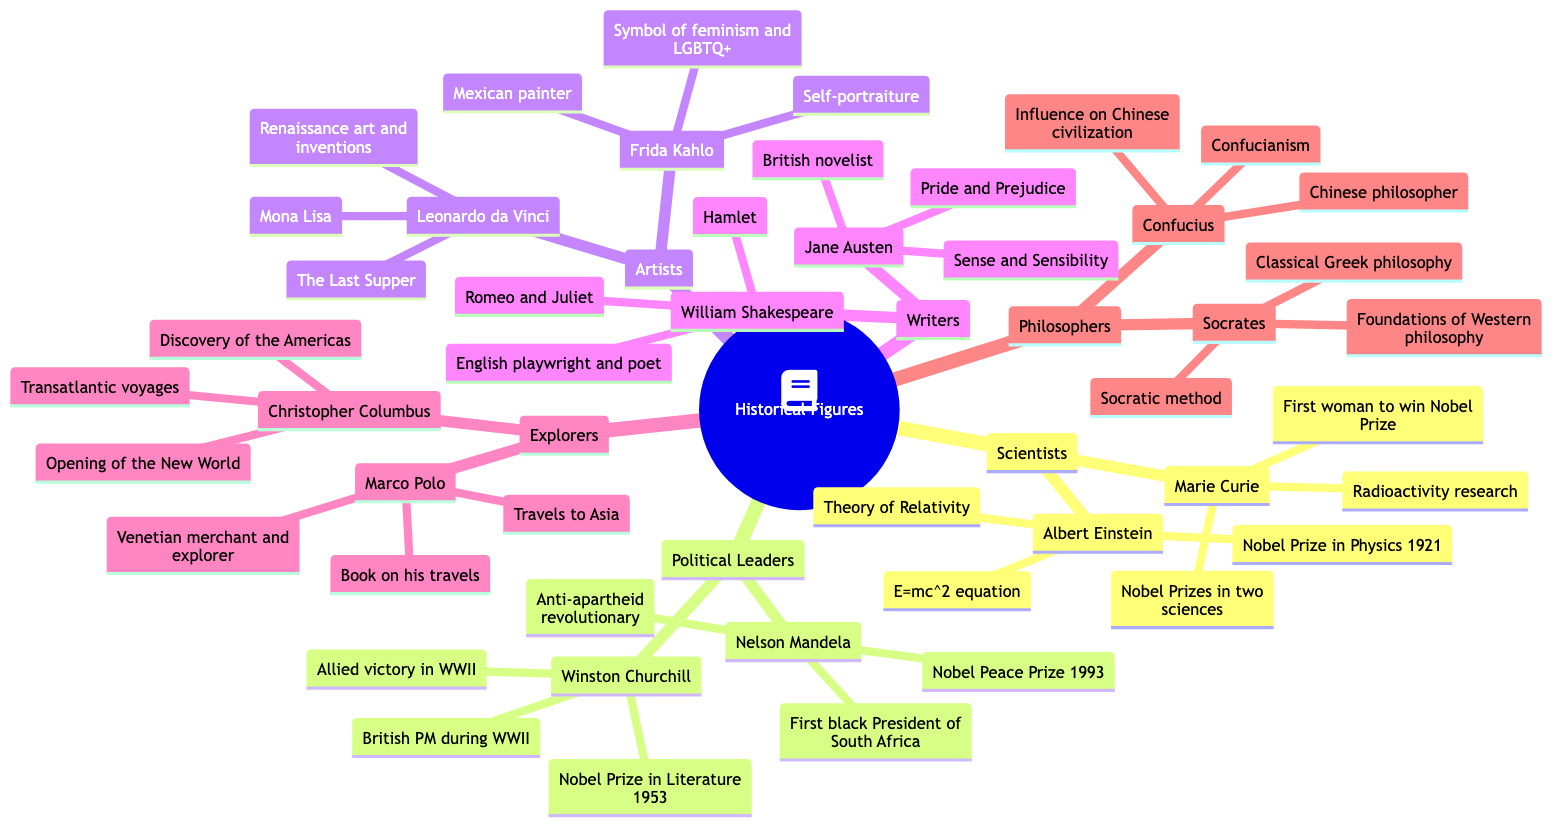What is Marie Curie known for? The diagram states that Marie Curie is known for "Radioactivity research." This is a direct line from her name to the known for category.
Answer: Radioactivity research How many political leaders are listed? The diagram shows two political leaders: Nelson Mandela and Winston Churchill, which can be counted directly from their respective nodes.
Answer: 2 Which artist created the "Mona Lisa"? The diagram indicates that Leonardo da Vinci is known for "Renaissance art and inventions" and specifically notes the "Mona Lisa" as one of his achievements.
Answer: Leonardo da Vinci What was Albert Einstein's major contribution? The diagram provides the information that Albert Einstein is known for the "Theory of Relativity," a significant contribution in the field of physics.
Answer: Theory of Relativity Who is recognized as the first black President of South Africa? According to the diagram, Nelson Mandela is specifically noted as the "First black President of South Africa," which is clearly stated in his achievements.
Answer: Nelson Mandela Which philosopher is linked with the Socratic method? By examining the diagram, Socrates is directly associated with the "Socratic method" under his achievements, linking him uniquely to this philosophical concept.
Answer: Socrates What are the two notable achievements of Frida Kahlo? The diagram lists her achievements as "Symbol of feminism and LGBTQ+ movements" and "Self-portraiture," which are presented as a direct node beneath her name.
Answer: Symbol of feminism and LGBTQ+ movements; Self-portraiture How many scientists are featured in the diagram? The diagram includes two scientists: Marie Curie and Albert Einstein, which can be counted directly from the corresponding nodes under the Scientists category.
Answer: 2 Which explorer is known for transatlantic voyages? The diagram clearly states that Christopher Columbus is known for "Transatlantic voyages," which links directly to his achievements.
Answer: Christopher Columbus What significant event is linked to Christopher Columbus? The diagram specifies that Columbus's achievements include the "Discovery of the Americas (1492)," detailing a crucial historical moment associated with his voyages.
Answer: Discovery of the Americas (1492) 